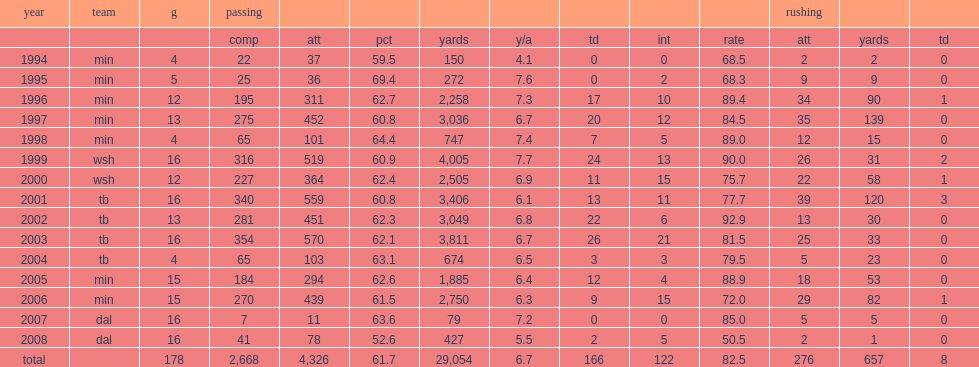In 1999, how many passing yards did johnson achieve? 4005.0. In 1999, how many touchdowns did johnson achieve? 24.0. In 1999, how many interceptions did johnson achieve? 13.0. In 1999, what was a passer rating did johnson achieve? 90.0. Help me parse the entirety of this table. {'header': ['year', 'team', 'g', 'passing', '', '', '', '', '', '', '', 'rushing', '', ''], 'rows': [['', '', '', 'comp', 'att', 'pct', 'yards', 'y/a', 'td', 'int', 'rate', 'att', 'yards', 'td'], ['1994', 'min', '4', '22', '37', '59.5', '150', '4.1', '0', '0', '68.5', '2', '2', '0'], ['1995', 'min', '5', '25', '36', '69.4', '272', '7.6', '0', '2', '68.3', '9', '9', '0'], ['1996', 'min', '12', '195', '311', '62.7', '2,258', '7.3', '17', '10', '89.4', '34', '90', '1'], ['1997', 'min', '13', '275', '452', '60.8', '3,036', '6.7', '20', '12', '84.5', '35', '139', '0'], ['1998', 'min', '4', '65', '101', '64.4', '747', '7.4', '7', '5', '89.0', '12', '15', '0'], ['1999', 'wsh', '16', '316', '519', '60.9', '4,005', '7.7', '24', '13', '90.0', '26', '31', '2'], ['2000', 'wsh', '12', '227', '364', '62.4', '2,505', '6.9', '11', '15', '75.7', '22', '58', '1'], ['2001', 'tb', '16', '340', '559', '60.8', '3,406', '6.1', '13', '11', '77.7', '39', '120', '3'], ['2002', 'tb', '13', '281', '451', '62.3', '3,049', '6.8', '22', '6', '92.9', '13', '30', '0'], ['2003', 'tb', '16', '354', '570', '62.1', '3,811', '6.7', '26', '21', '81.5', '25', '33', '0'], ['2004', 'tb', '4', '65', '103', '63.1', '674', '6.5', '3', '3', '79.5', '5', '23', '0'], ['2005', 'min', '15', '184', '294', '62.6', '1,885', '6.4', '12', '4', '88.9', '18', '53', '0'], ['2006', 'min', '15', '270', '439', '61.5', '2,750', '6.3', '9', '15', '72.0', '29', '82', '1'], ['2007', 'dal', '16', '7', '11', '63.6', '79', '7.2', '0', '0', '85.0', '5', '5', '0'], ['2008', 'dal', '16', '41', '78', '52.6', '427', '5.5', '2', '5', '50.5', '2', '1', '0'], ['total', '', '178', '2,668', '4,326', '61.7', '29,054', '6.7', '166', '122', '82.5', '276', '657', '8']]} 